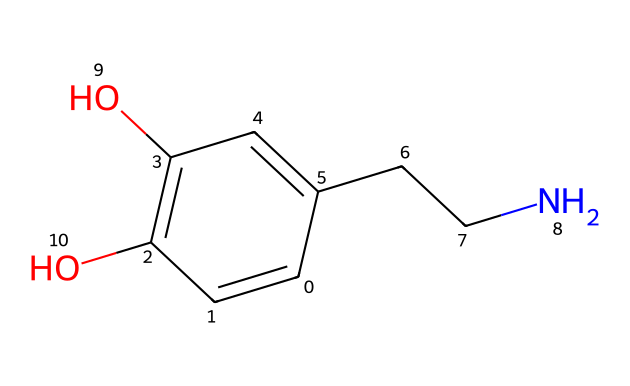What is the molecular formula of dopamine? To determine the molecular formula, we can identify and count the distinct atoms present in the SMILES representation. The SMILES structure shows carbon (C), hydrogen (H), nitrogen (N), and oxygen (O). Counting each, we find: 8 carbons, 11 hydrogens, 1 nitrogen, and 2 oxygens, which gives us the formula C8H11NO2.
Answer: C8H11NO2 How many rings are present in the dopamine structure? By analyzing the SMILES representation, we can identify the presence of ring structures. The "C1" indicates the start of a ring, but upon examining the structure, there are no additional ring markers leading to another "C" indicating a second connection back to "C1". Thus, there are no rings present in this molecule.
Answer: 0 What type of functional groups are present in dopamine? Looking at the chemical structure, we can identify the presence of hydroxyl groups (–OH) indicated by "O" bonded to carbon atoms. Additionally, there’s an amine group (–NH) indicated by the nitrogen atom connected to a carbon chain. Thus, we see both hydroxyl and amine functional groups.
Answer: hydroxyl and amine How many oxygen atoms are in the dopamine structure? The SMILES notation reflects two separate "O" atoms present in the structure. This can easily be counted directly from the representation without needing additional chemical knowledge.
Answer: 2 Which part of the dopamine molecule is primarily responsible for its role as a neurotransmitter? Investigating the structure, the nitrogen in the amine group (–NH) plays a crucial role in the neurotransmitter activity, as it can interact with receptors in the nervous system. The presence of the amine group is essential for neurotransmitter function.
Answer: nitrogen 